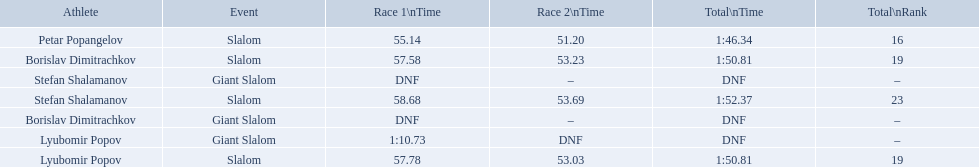Which event is the giant slalom? Giant Slalom, Giant Slalom, Giant Slalom. Which one is lyubomir popov? Lyubomir Popov. What is race 1 tim? 1:10.73. 